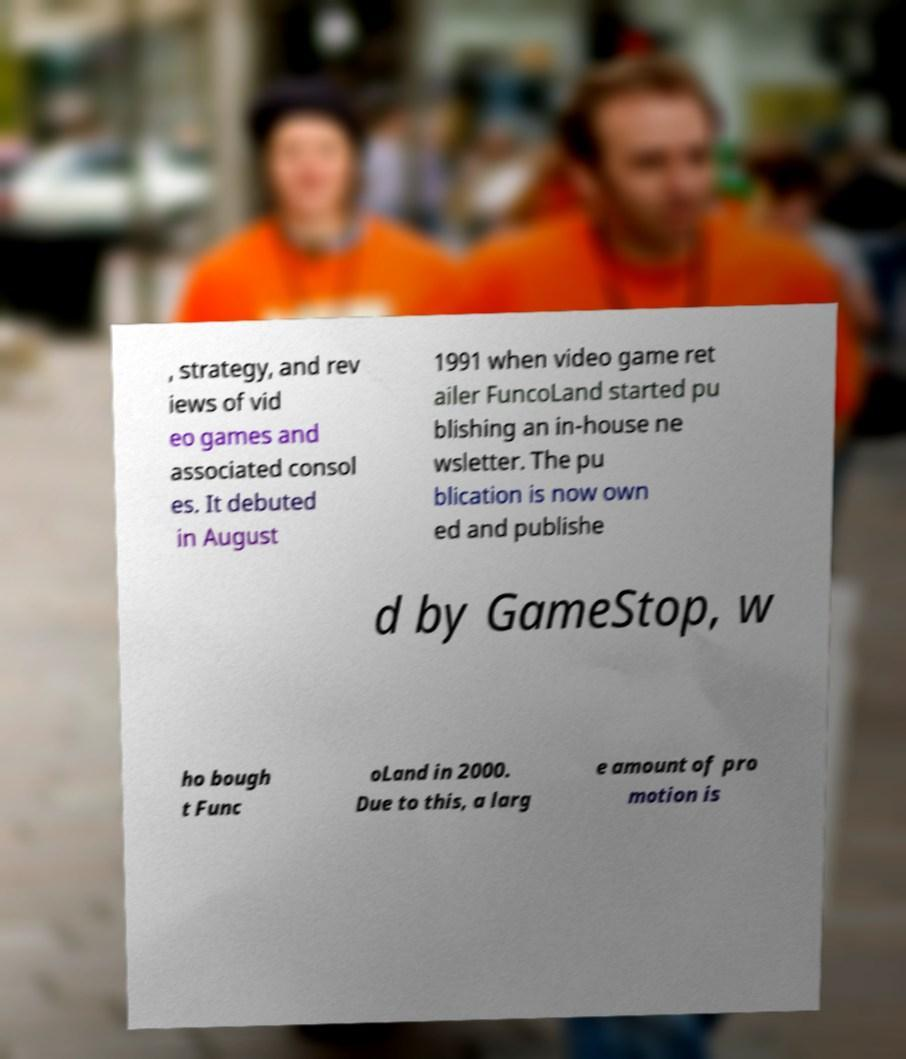Please read and relay the text visible in this image. What does it say? , strategy, and rev iews of vid eo games and associated consol es. It debuted in August 1991 when video game ret ailer FuncoLand started pu blishing an in-house ne wsletter. The pu blication is now own ed and publishe d by GameStop, w ho bough t Func oLand in 2000. Due to this, a larg e amount of pro motion is 